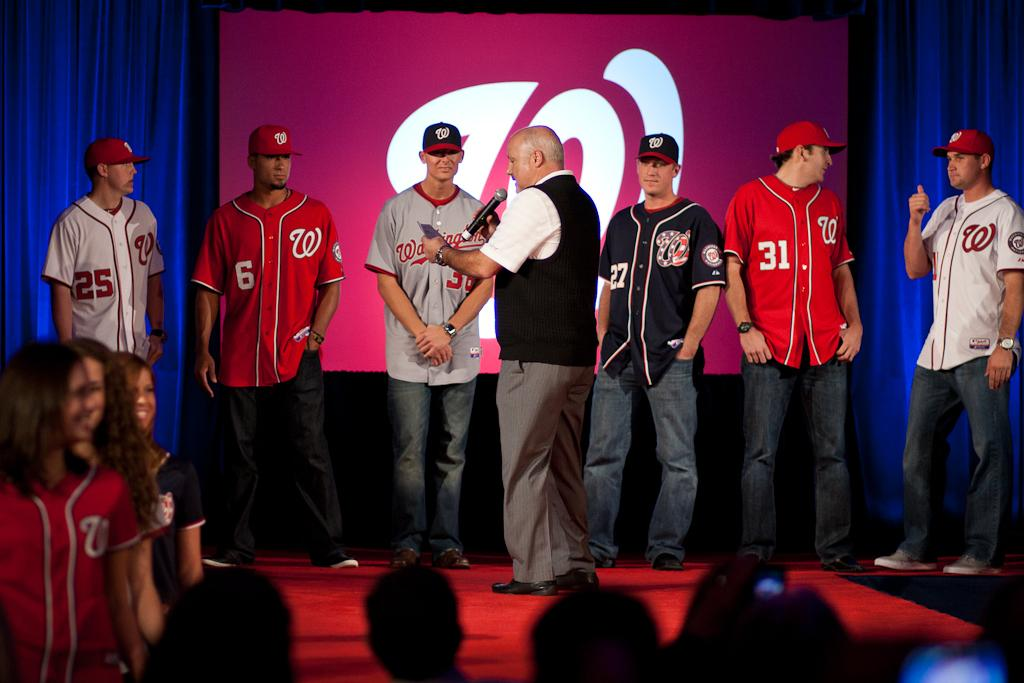<image>
Describe the image concisely. People in front of a presentation screen wear baseball jerseys with numbers like 25, 6, 27, and 31. 